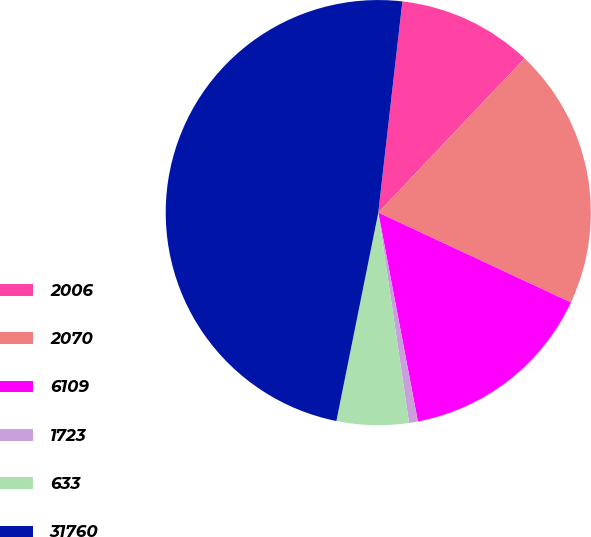Convert chart. <chart><loc_0><loc_0><loc_500><loc_500><pie_chart><fcel>2006<fcel>2070<fcel>6109<fcel>1723<fcel>633<fcel>31760<nl><fcel>10.27%<fcel>19.87%<fcel>15.07%<fcel>0.67%<fcel>5.47%<fcel>48.65%<nl></chart> 